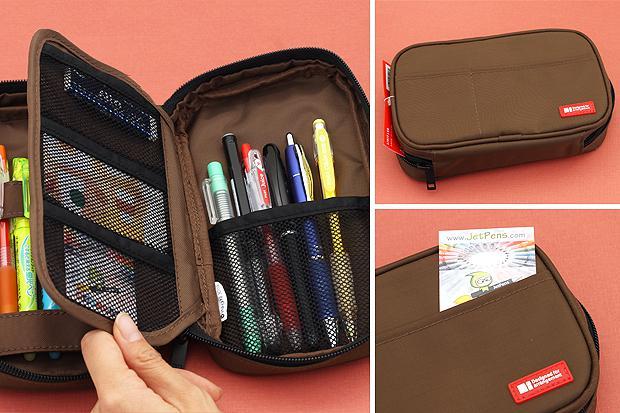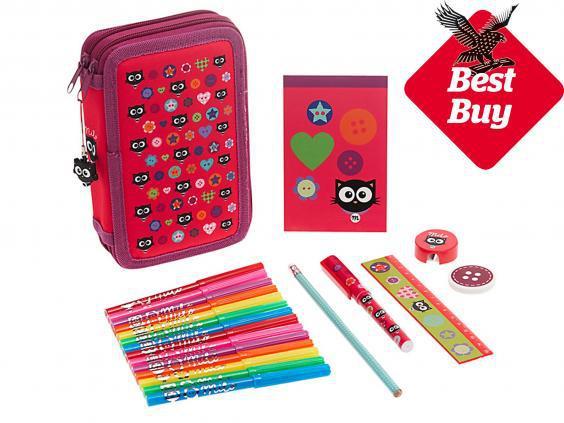The first image is the image on the left, the second image is the image on the right. Considering the images on both sides, is "An open pencil case contains at least one stick-shaped item with a cartoony face shape on the end." valid? Answer yes or no. No. 